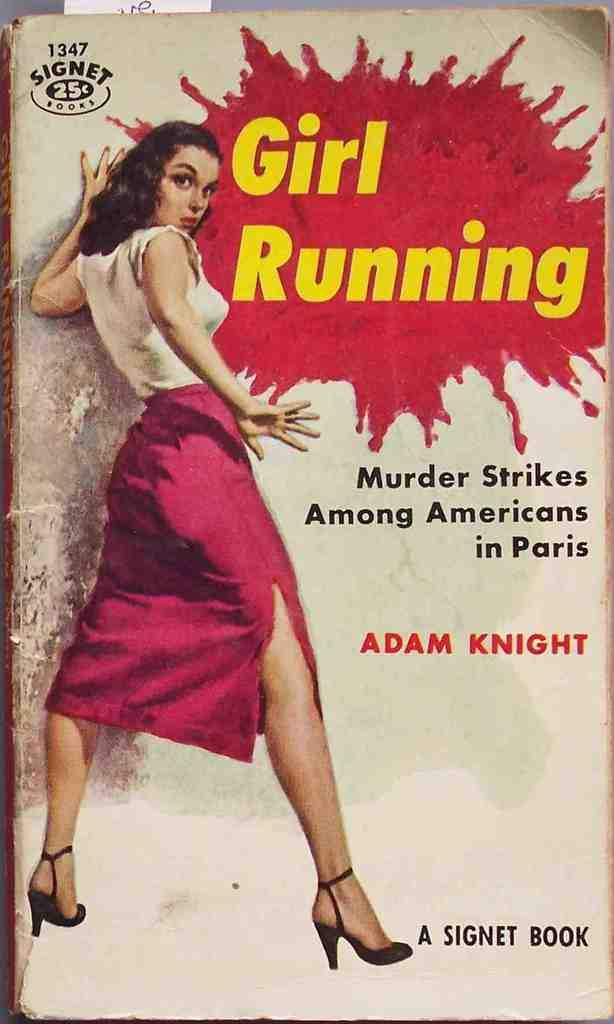<image>
Write a terse but informative summary of the picture. A 25 cent Signet Book features a woman in a skirt and high heels on the cover. 